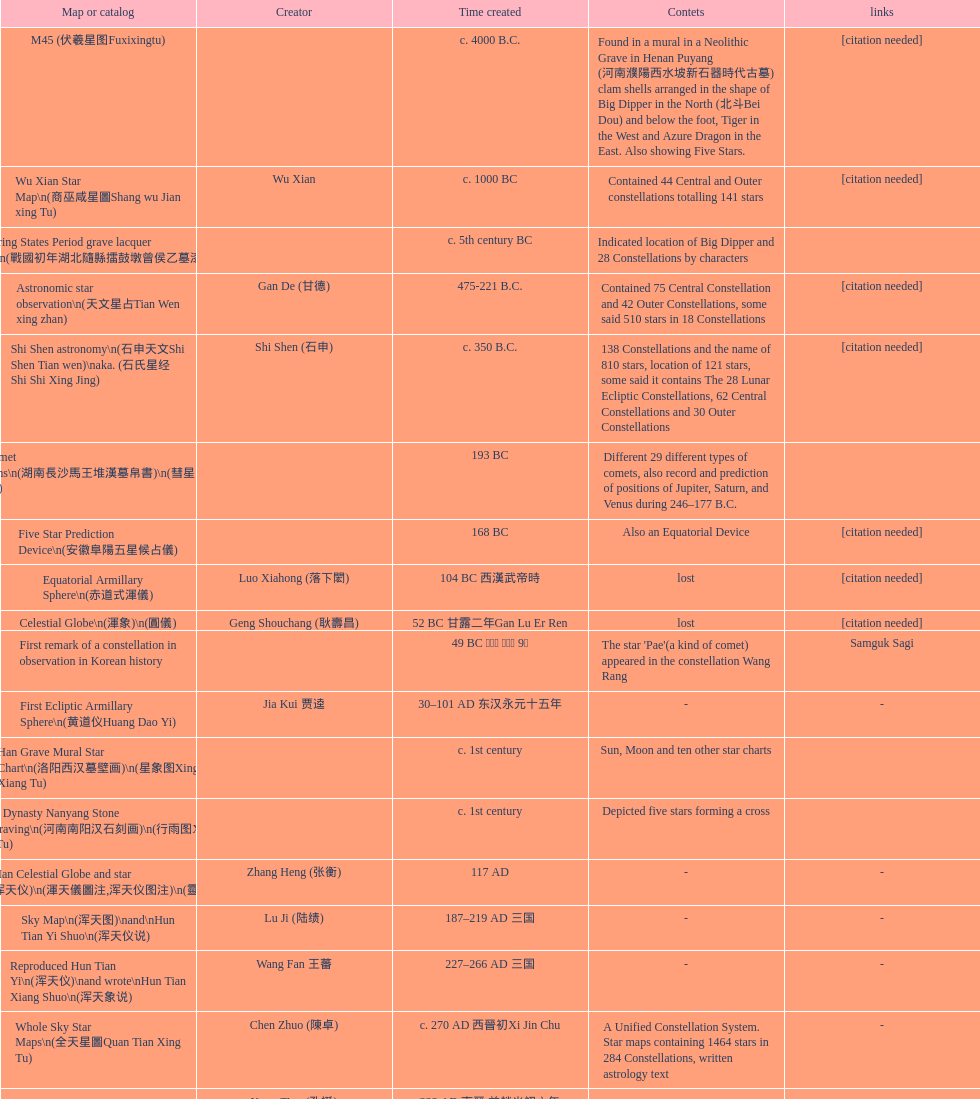Which star map was created earlier, celestial globe or the han grave mural star chart? Celestial Globe. 